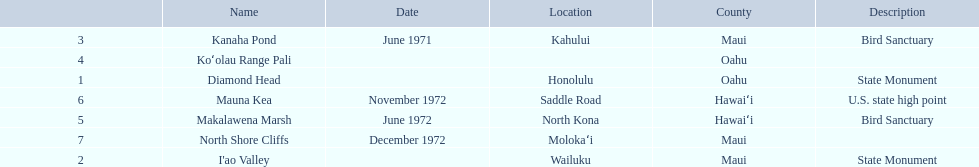What are the names of the different hawaiian national landmarks Diamond Head, I'ao Valley, Kanaha Pond, Koʻolau Range Pali, Makalawena Marsh, Mauna Kea, North Shore Cliffs. Which landmark does not have a location listed? Koʻolau Range Pali. 